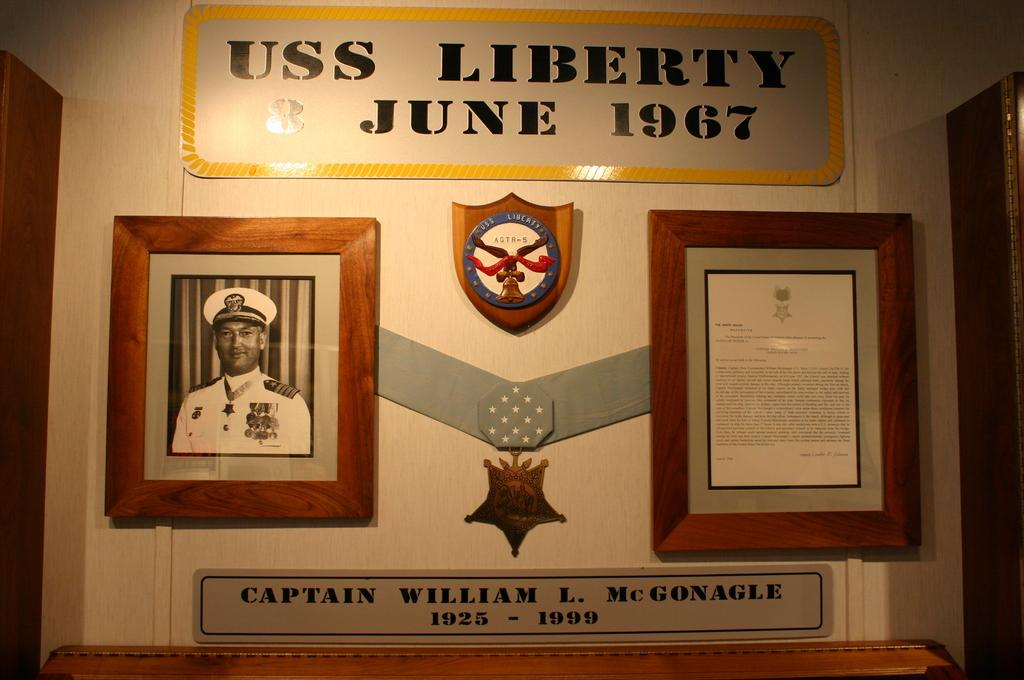<image>
Provide a brief description of the given image. Two papers framed on a wall with the words "Captain William L. McGonagle" under them. 